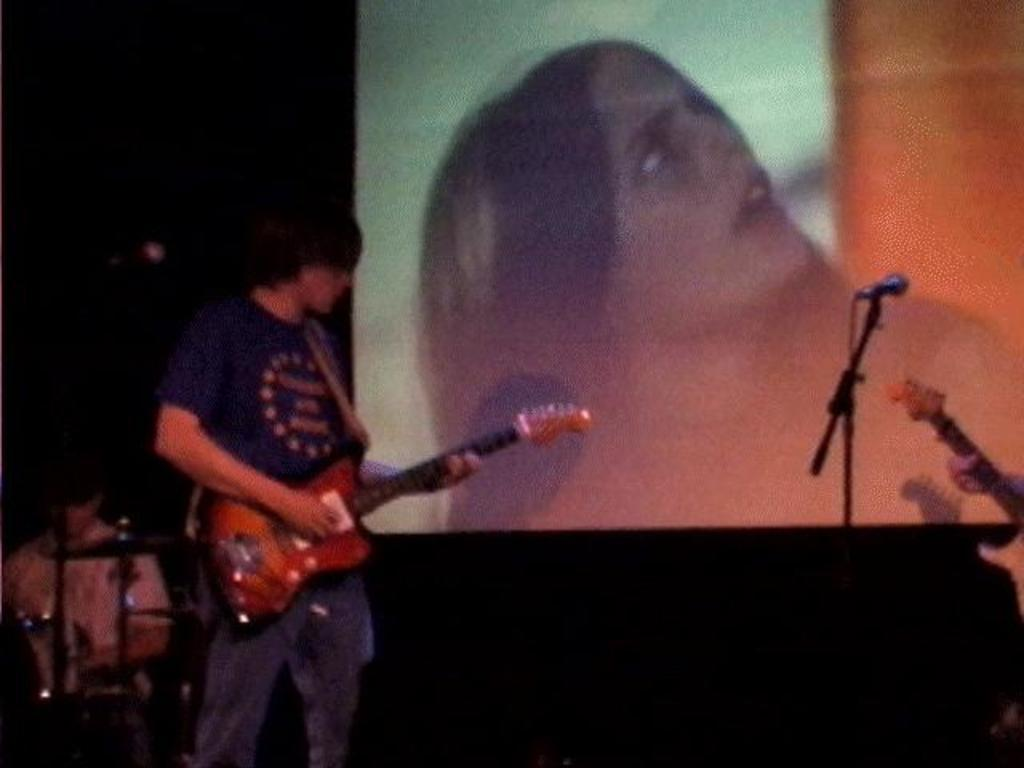Who is in the image? There is a man in the image. What is the man holding in the image? The man is holding a guitar. What is the man doing with the guitar? The man is playing the guitar. What can be seen in the background of the image? There is a microphone and a screen in the background. How many grapes are on the man's head in the image? There are no grapes present on the man's head in the image. What type of fan is visible in the image? There is no fan visible in the image. 